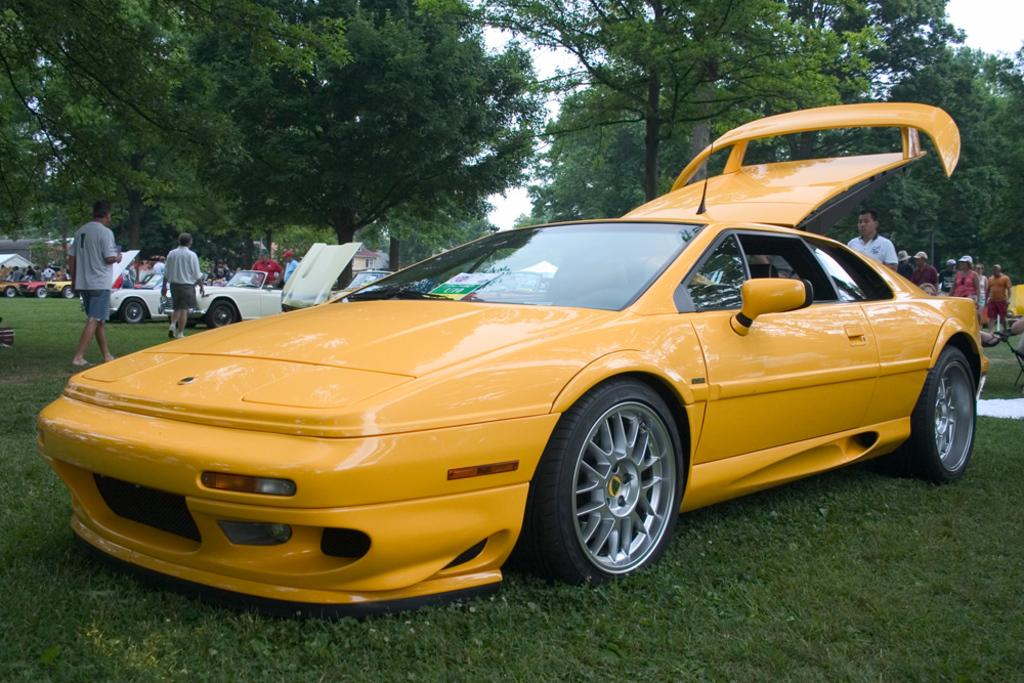What is the unusual location of the parked cars in the image? The cars are parked on the grass in the image. What are the people near the cars doing? People are standing beside the cars in the image. What can be seen in the background of the image? There are trees and the sky visible in the background of the image. What type of crayon is being used to draw on the cars in the image? There is no crayon or drawing on the cars in the image; people are simply standing beside them. How are the cars being used to transport people in the image? The cars are parked on the grass and not being used for transportation in the image. 